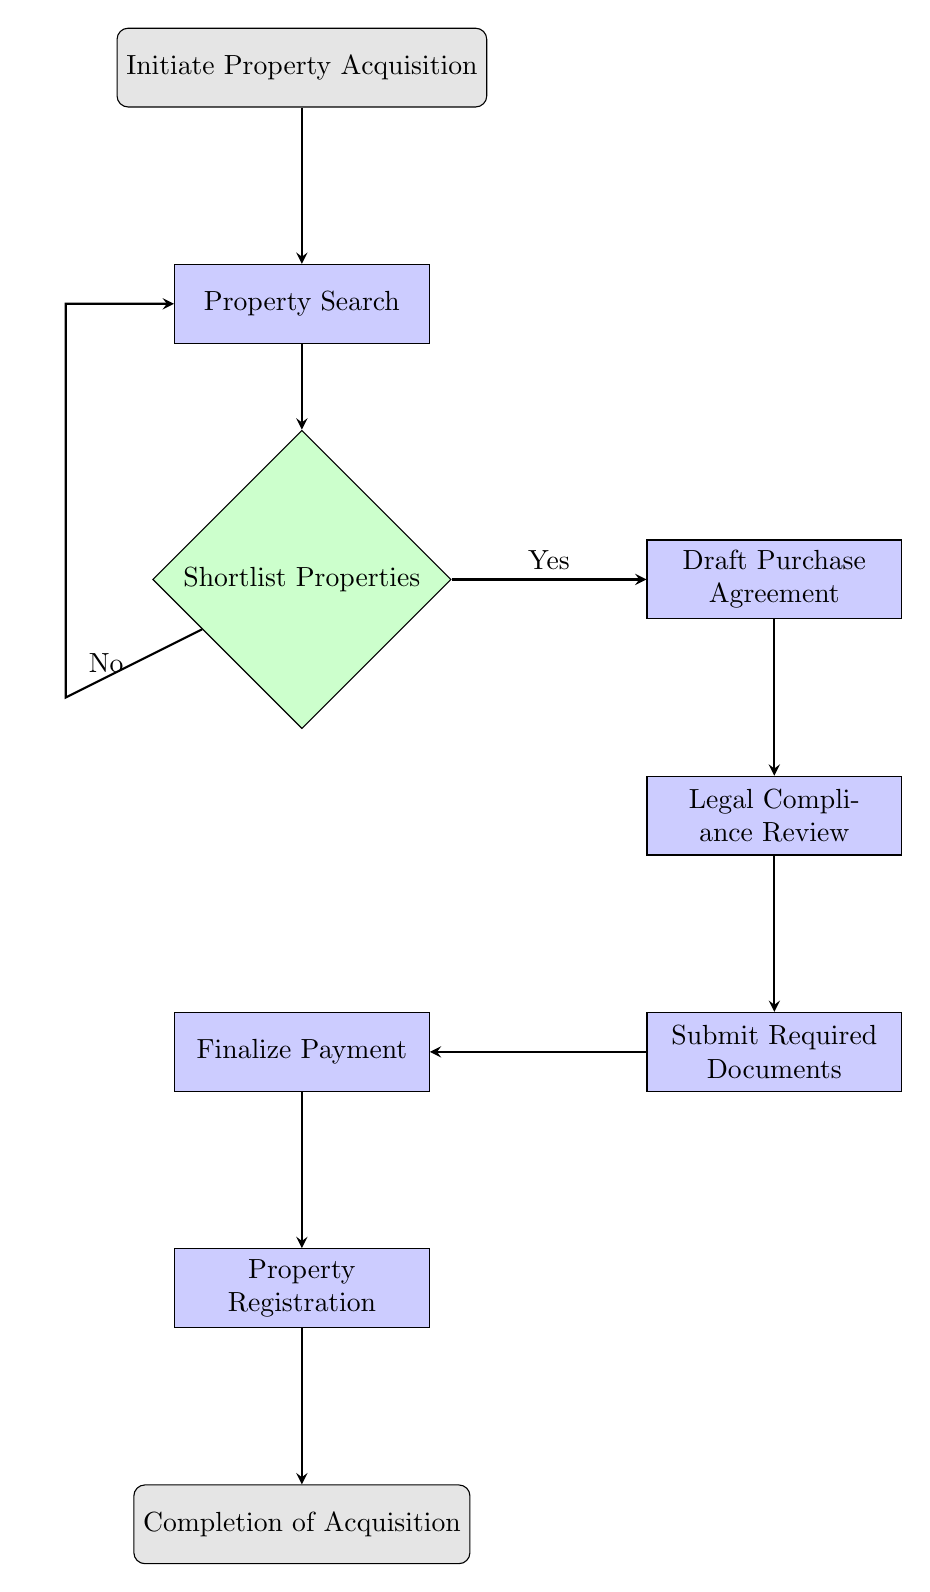What is the first step in the flowchart? The first step is labeled "Initiate Property Acquisition," which is where the process begins according to the diagram.
Answer: Initiate Property Acquisition How many decision nodes are present in the diagram? There is one decision node in the diagram, which is "Shortlist Properties" where a choice is made based on criteria.
Answer: 1 What happens after the "Legal Compliance Review"? After the "Legal Compliance Review," the next step is "Submit Required Documents," indicating the flow continues after ensuring compliance.
Answer: Submit Required Documents What must be done before property registration? Before "Property Registration," the step "Finalize Payment" must be completed, as indicated by the directional flow leading to registration.
Answer: Finalize Payment If the decision at "Shortlist Properties" is "No," where does the flowchart direct to? If the decision is "No," the flowchart directs back to "Property Search," indicating a return to the initial search process for identifying properties.
Answer: Property Search What is the penultimate step in the flowchart? The penultimate step, right before the final step, is "Property Registration," which implies that all previous steps must be completed before this action.
Answer: Property Registration Which process requires collaboration with legal experts? The process that requires collaboration with legal experts is "Draft Purchase Agreement," highlighted as needing legal involvement in its description.
Answer: Draft Purchase Agreement How does the flowchart conclude? The flowchart concludes with the step labeled "Completion of Acquisition," marking the end of the entire property acquisition process.
Answer: Completion of Acquisition 